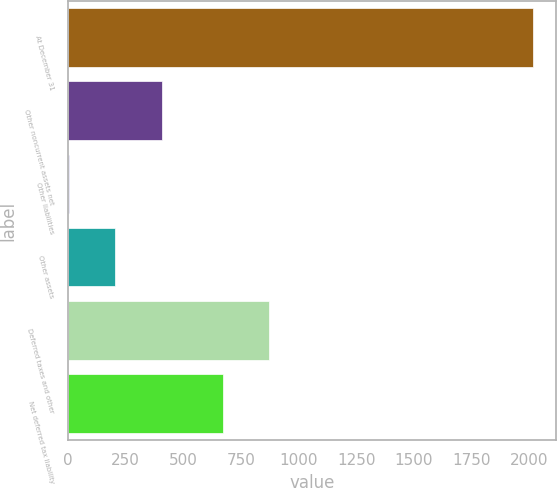<chart> <loc_0><loc_0><loc_500><loc_500><bar_chart><fcel>At December 31<fcel>Other noncurrent assets net<fcel>Other liabilities<fcel>Other assets<fcel>Deferred taxes and other<fcel>Net deferred tax liability<nl><fcel>2016<fcel>408.24<fcel>6.3<fcel>207.27<fcel>872.67<fcel>671.7<nl></chart> 